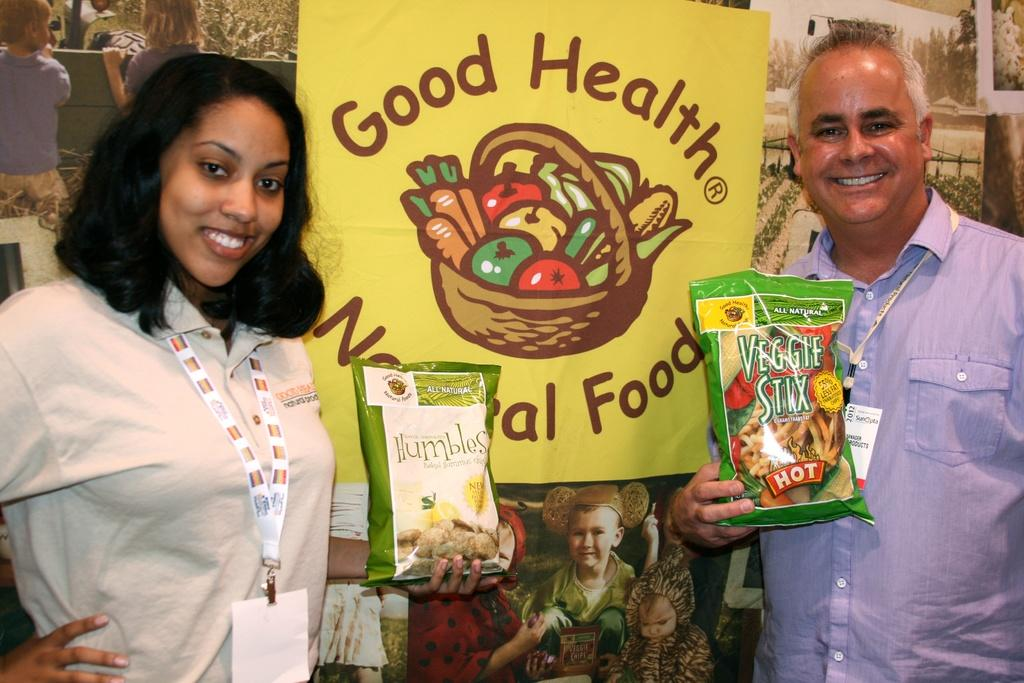How many people are present in the image? There are two people standing in the image. What are the people doing in the image? The people are standing and holding something. What can be seen in the background of the image? There is a yellow banner in the background. What is written on the banner? Unfortunately, we cannot determine what is written on the banner from the given facts. How many cushions are visible on the ground in the image? There is no mention of cushions in the given facts, so we cannot determine if any are visible in the image. --- Facts: 1. There is a person sitting on a chair in the image. 2. The person is holding a book. 3. The book has a red cover. 4. There is a table next to the chair. 5. A lamp is on the table. Absurd Topics: parrot, dance, ocean Conversation: What is the person in the image doing? The person is sitting on a chair in the image. What is the person holding while sitting on the chair? The person is holding a book. Can you describe the book's appearance? The book has a red cover. What is located next to the chair in the image? There is a table next to the chair. What object is on the table? A lamp is on the table. Reasoning: Let's think step by step in order to produce the conversation. We start by identifying the main subject in the image, which is the person sitting on a chair. Then, we describe what the person is holding, which is a book with a red cover. Next, we mention the presence of a table next to the chair and a lamp on the table. Each question is designed to elicit a specific detail about the image that is known from the provided facts. Absurd Question/Answer: Can you tell me how many parrots are sitting on the person's shoulder in the image? There is no mention of parrots in the given facts, so we cannot determine if any are present in the image. 